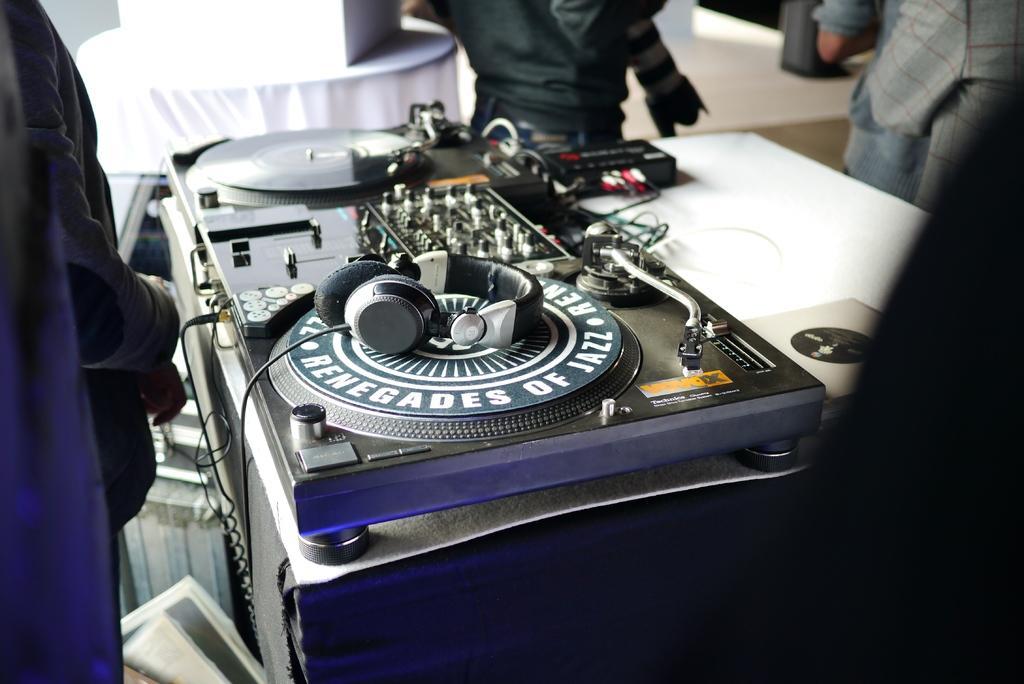Please provide a concise description of this image. In this picture, we see a music recording equipment is placed on the white table. On the recording equipment, we see a headset. Beside the table, we see many people standing. In the background, we see the table which is covered with white color cloth. 